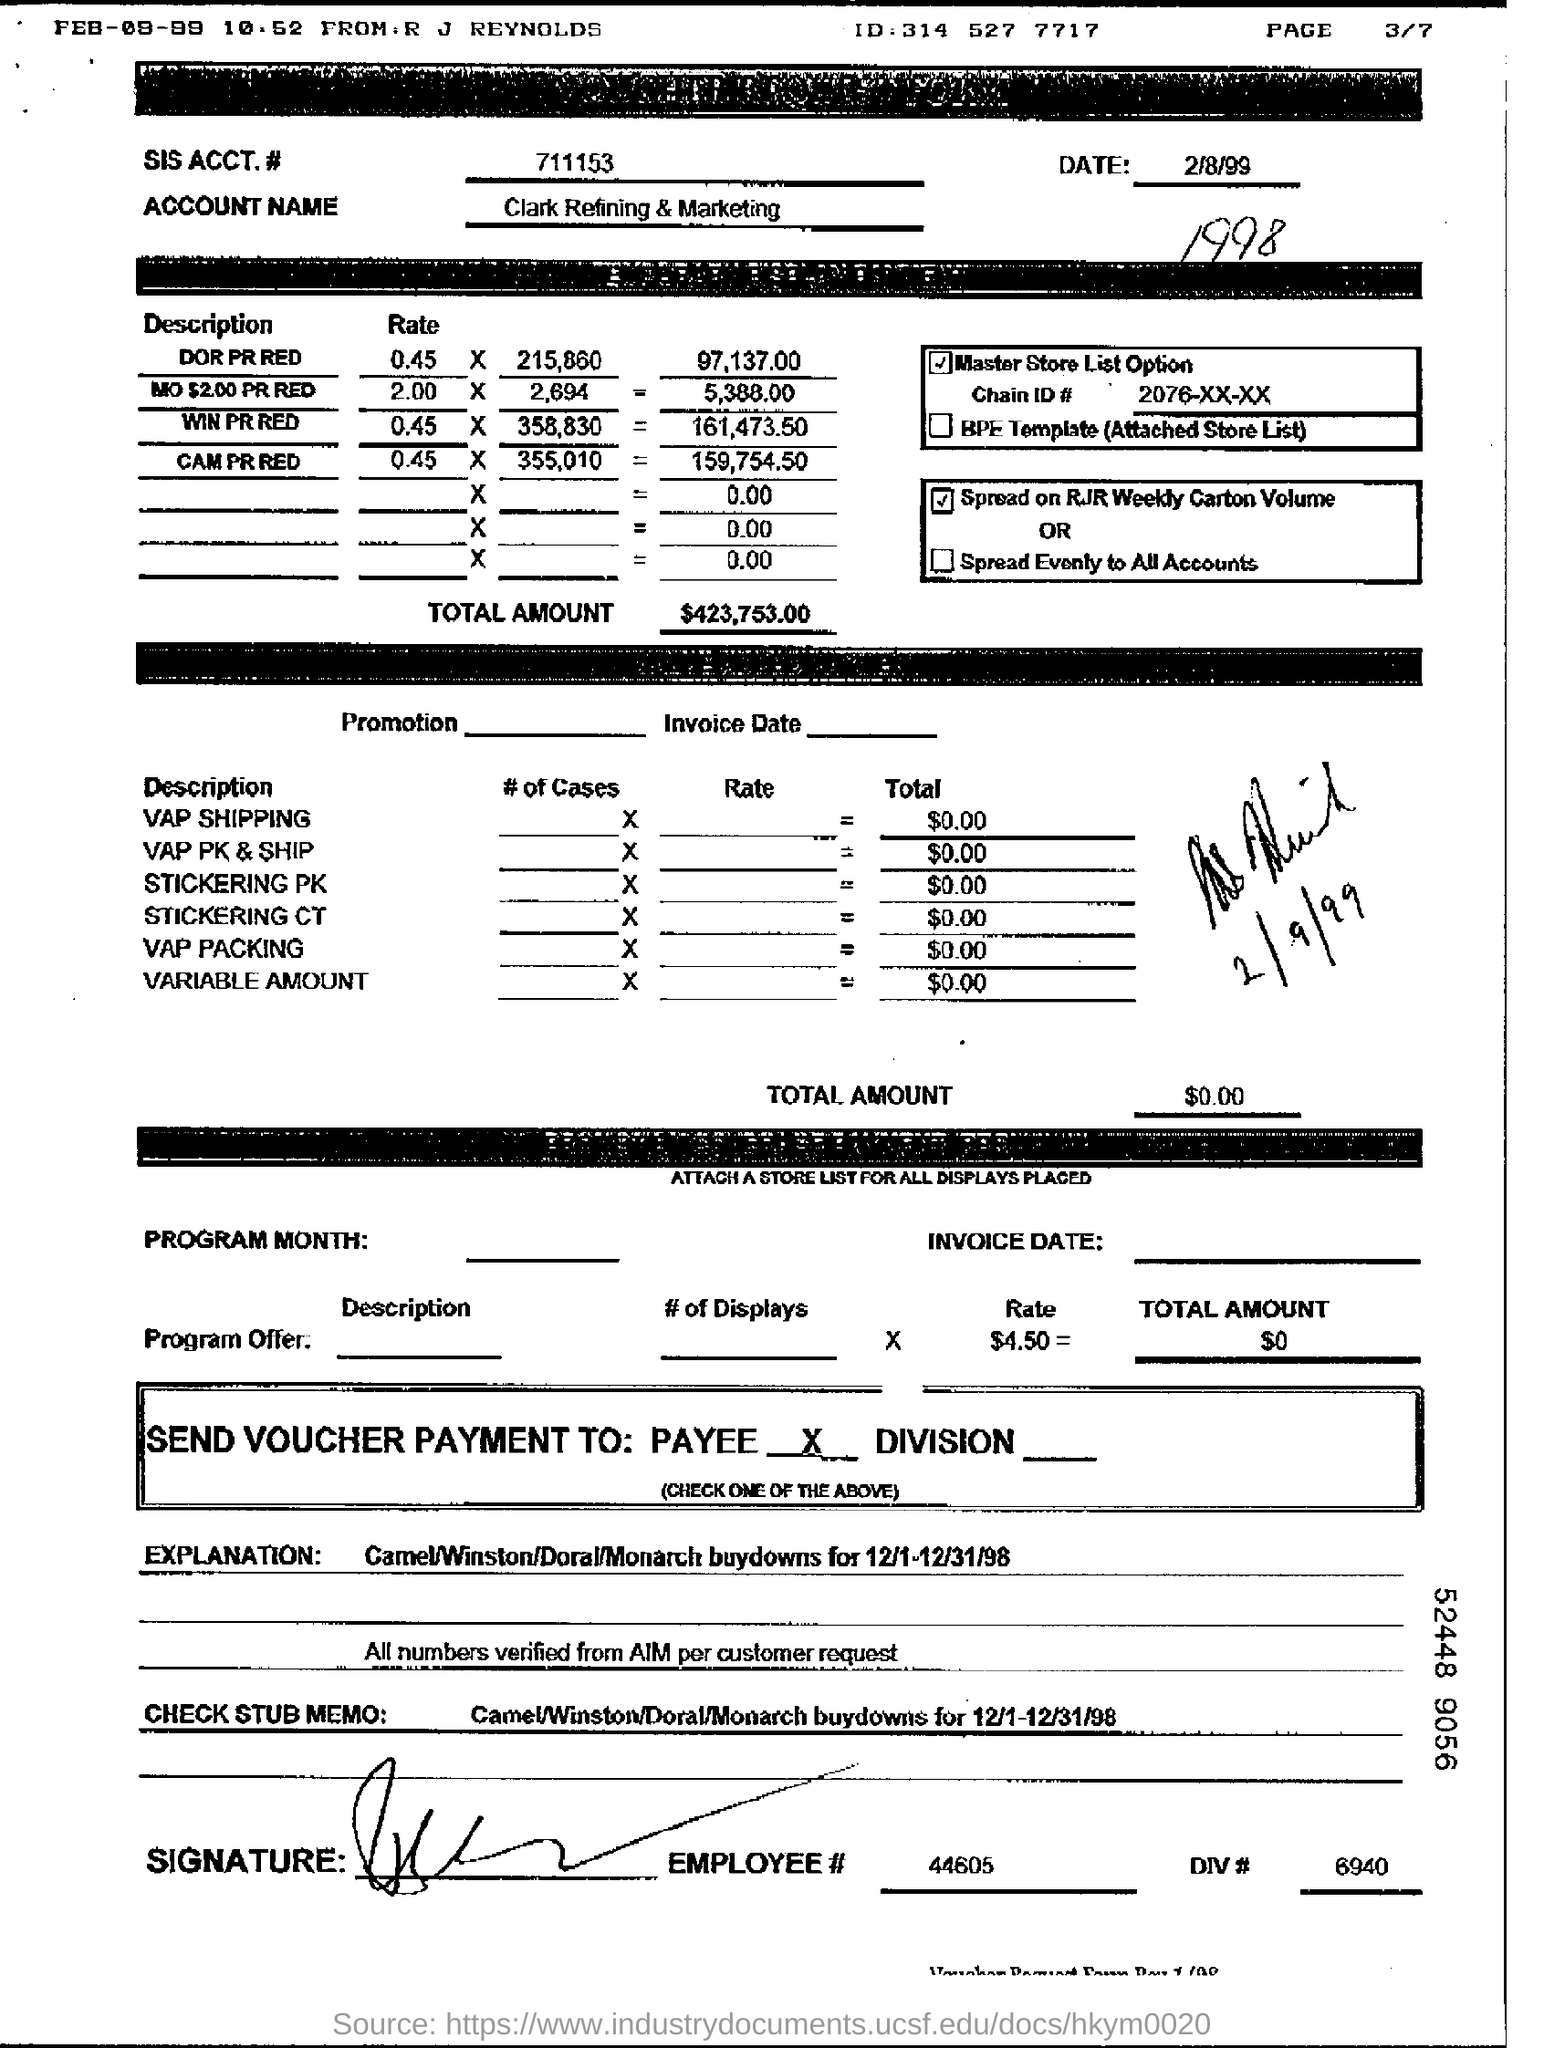Draw attention to some important aspects in this diagram. The SIS ACCT# given in the form is 711153... The account name is Clark Refining & Marketing. The employee number mentioned at the bottom is 44605. What is the date mentioned? It is 2/8/99. 